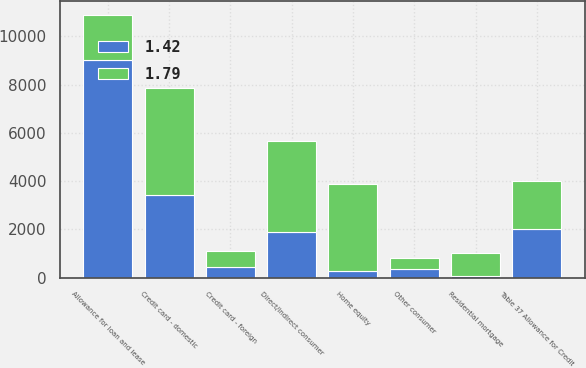Convert chart to OTSL. <chart><loc_0><loc_0><loc_500><loc_500><stacked_bar_chart><ecel><fcel>Table 37 Allowance for Credit<fcel>Allowance for loan and lease<fcel>Residential mortgage<fcel>Home equity<fcel>Credit card - domestic<fcel>Credit card - foreign<fcel>Direct/Indirect consumer<fcel>Other consumer<nl><fcel>1.79<fcel>2008<fcel>1885<fcel>964<fcel>3597<fcel>4469<fcel>639<fcel>3777<fcel>461<nl><fcel>1.42<fcel>2007<fcel>9016<fcel>78<fcel>286<fcel>3410<fcel>453<fcel>1885<fcel>346<nl></chart> 